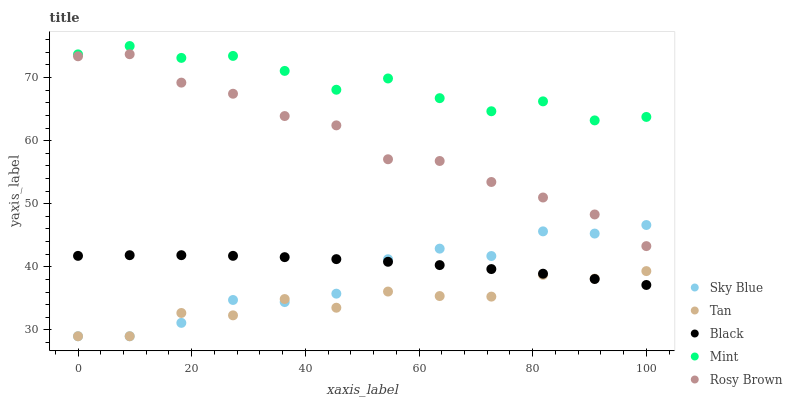Does Tan have the minimum area under the curve?
Answer yes or no. Yes. Does Mint have the maximum area under the curve?
Answer yes or no. Yes. Does Rosy Brown have the minimum area under the curve?
Answer yes or no. No. Does Rosy Brown have the maximum area under the curve?
Answer yes or no. No. Is Black the smoothest?
Answer yes or no. Yes. Is Tan the roughest?
Answer yes or no. Yes. Is Rosy Brown the smoothest?
Answer yes or no. No. Is Rosy Brown the roughest?
Answer yes or no. No. Does Sky Blue have the lowest value?
Answer yes or no. Yes. Does Rosy Brown have the lowest value?
Answer yes or no. No. Does Mint have the highest value?
Answer yes or no. Yes. Does Rosy Brown have the highest value?
Answer yes or no. No. Is Tan less than Rosy Brown?
Answer yes or no. Yes. Is Mint greater than Black?
Answer yes or no. Yes. Does Black intersect Sky Blue?
Answer yes or no. Yes. Is Black less than Sky Blue?
Answer yes or no. No. Is Black greater than Sky Blue?
Answer yes or no. No. Does Tan intersect Rosy Brown?
Answer yes or no. No. 